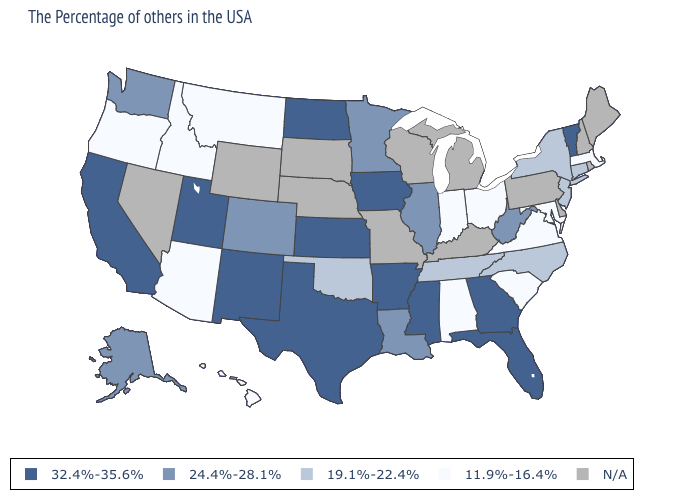What is the value of Missouri?
Quick response, please. N/A. Among the states that border Wyoming , which have the lowest value?
Be succinct. Montana, Idaho. What is the highest value in the USA?
Be succinct. 32.4%-35.6%. What is the value of Oregon?
Keep it brief. 11.9%-16.4%. Is the legend a continuous bar?
Short answer required. No. What is the highest value in the USA?
Quick response, please. 32.4%-35.6%. What is the value of Connecticut?
Answer briefly. 19.1%-22.4%. Among the states that border Montana , which have the lowest value?
Concise answer only. Idaho. Which states hav the highest value in the South?
Answer briefly. Florida, Georgia, Mississippi, Arkansas, Texas. Name the states that have a value in the range 11.9%-16.4%?
Give a very brief answer. Massachusetts, Maryland, Virginia, South Carolina, Ohio, Indiana, Alabama, Montana, Arizona, Idaho, Oregon, Hawaii. Name the states that have a value in the range 19.1%-22.4%?
Short answer required. Connecticut, New York, New Jersey, North Carolina, Tennessee, Oklahoma. Name the states that have a value in the range 11.9%-16.4%?
Be succinct. Massachusetts, Maryland, Virginia, South Carolina, Ohio, Indiana, Alabama, Montana, Arizona, Idaho, Oregon, Hawaii. Name the states that have a value in the range 11.9%-16.4%?
Keep it brief. Massachusetts, Maryland, Virginia, South Carolina, Ohio, Indiana, Alabama, Montana, Arizona, Idaho, Oregon, Hawaii. Does New Jersey have the highest value in the Northeast?
Concise answer only. No. 